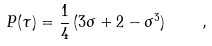Convert formula to latex. <formula><loc_0><loc_0><loc_500><loc_500>P ( \tau ) = \frac { 1 } { 4 } \, ( 3 \sigma + 2 - { \sigma } ^ { 3 } ) \quad ,</formula> 